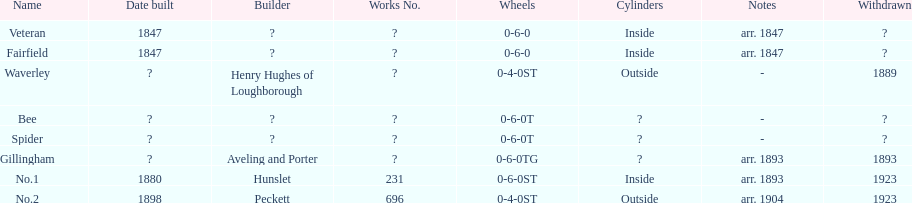Were there more with inside or outside cylinders? Inside. 